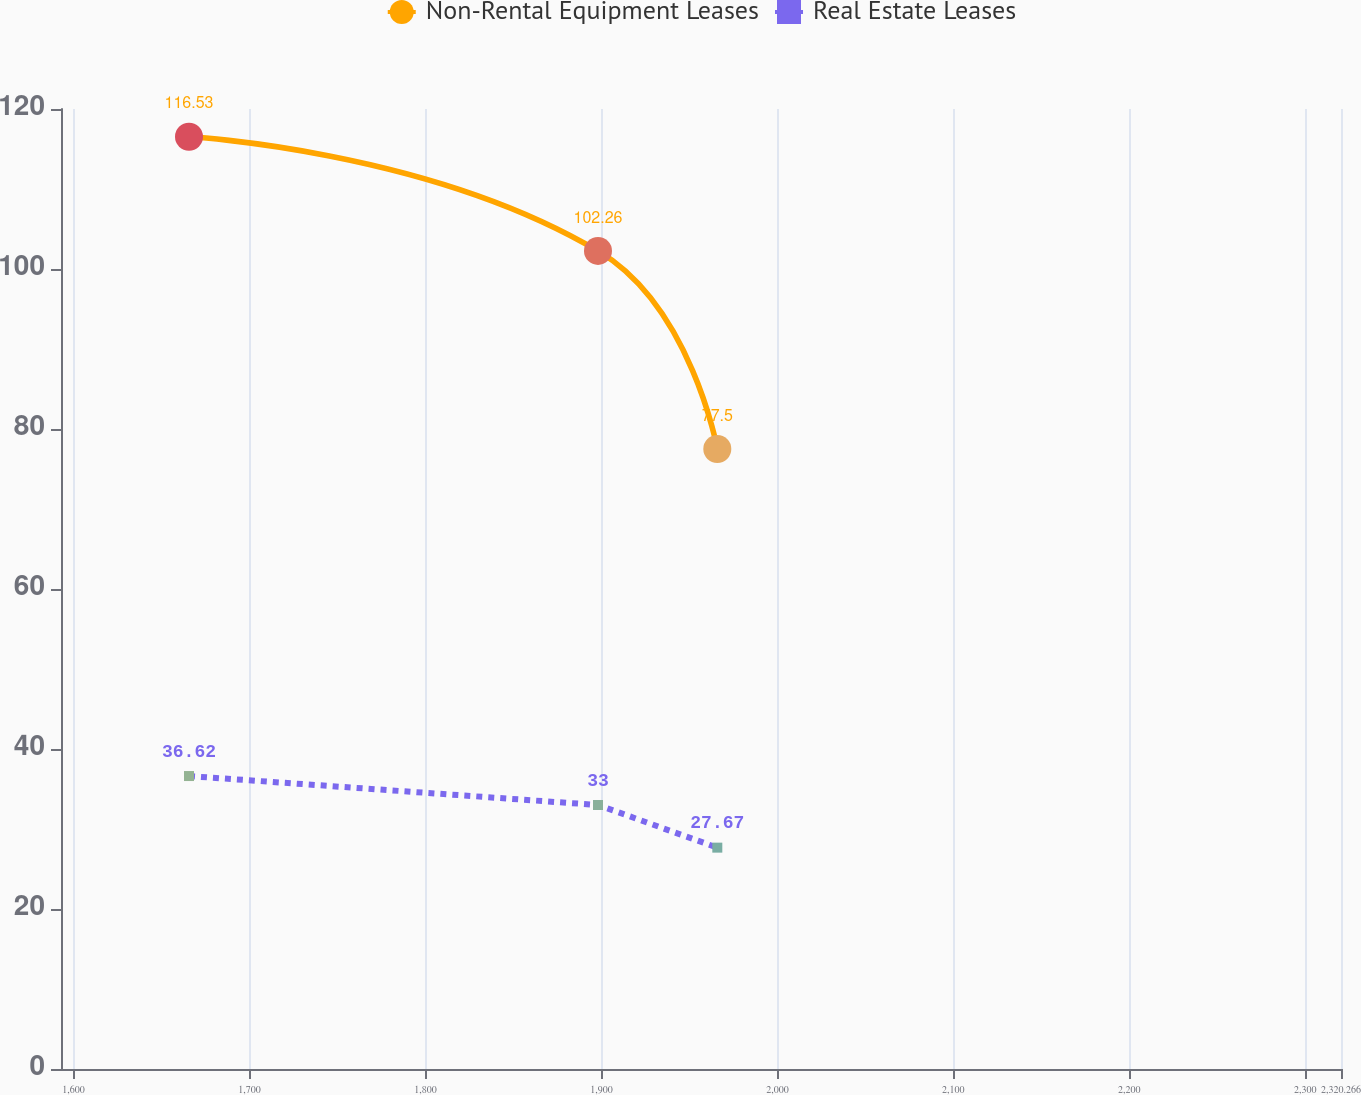Convert chart. <chart><loc_0><loc_0><loc_500><loc_500><line_chart><ecel><fcel>Non-Rental Equipment Leases<fcel>Real Estate Leases<nl><fcel>1665.66<fcel>116.53<fcel>36.62<nl><fcel>1898.06<fcel>102.26<fcel>33<nl><fcel>1965.86<fcel>77.5<fcel>27.67<nl><fcel>2325.2<fcel>44.54<fcel>21.09<nl><fcel>2393<fcel>30.68<fcel>13.85<nl></chart> 